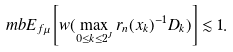<formula> <loc_0><loc_0><loc_500><loc_500>\ m b E _ { f \mu } \left [ w ( \max _ { 0 \leq k \leq 2 ^ { J } } r _ { n } ( x _ { k } ) ^ { - 1 } D _ { k } ) \right ] \lesssim 1 .</formula> 